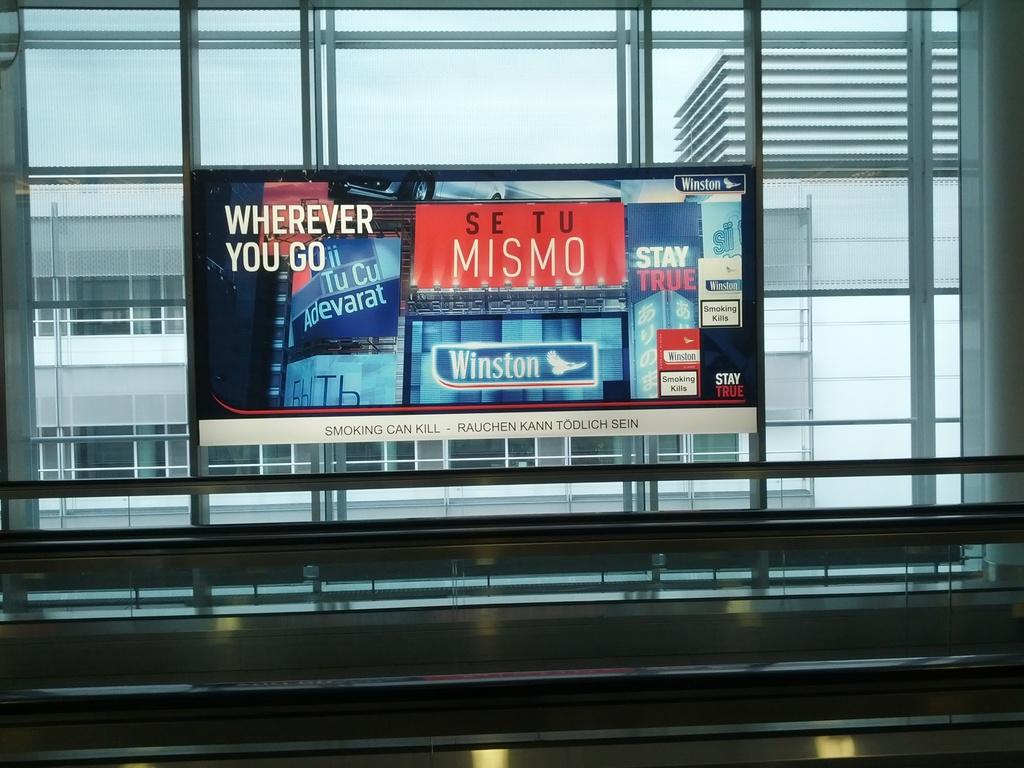What cigarette brand is being advertised?
Ensure brevity in your answer.  Winston. 